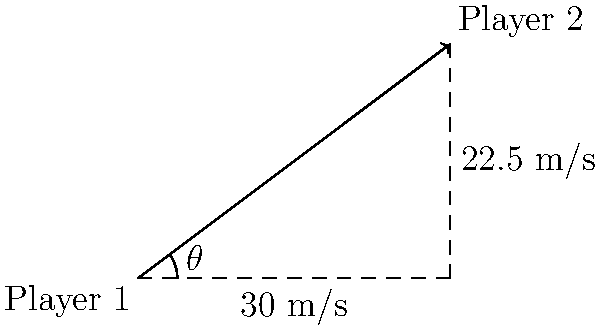In a crucial match at the Batumi Arena, two Dinamo Batumi players are passing the ball to each other. Player 1 kicks the ball towards Player 2 with a velocity of 30 m/s horizontally. Simultaneously, Player 2 runs towards the ball at 22.5 m/s at an angle of $\theta$ (as shown in the diagram). What is the magnitude of the resultant velocity vector of the ball relative to Player 2? To solve this problem, we'll use vector addition and the law of cosines. Let's break it down step-by-step:

1) First, we need to identify the vectors:
   - Vector A: Ball's velocity = 30 m/s (horizontal)
   - Vector B: Player 2's velocity = 22.5 m/s (at angle $\theta$)

2) The resultant vector R is the difference between these vectors: R = A - B

3) To find the magnitude of R, we can use the law of cosines:

   $$R^2 = A^2 + B^2 - 2AB \cos(\theta)$$

4) We know:
   A = 30 m/s
   B = 22.5 m/s
   $\theta = \tan^{-1}(3/4) = 36.87°$

5) Plugging these values into the formula:

   $$R^2 = 30^2 + 22.5^2 - 2(30)(22.5) \cos(36.87°)$$

6) Simplifying:
   $$R^2 = 900 + 506.25 - 1350(0.8)$$
   $$R^2 = 1406.25 - 1080 = 326.25$$

7) Taking the square root of both sides:
   $$R = \sqrt{326.25} = 18.06 \text{ m/s}$$

Therefore, the magnitude of the resultant velocity vector is approximately 18.06 m/s.
Answer: 18.06 m/s 